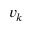Convert formula to latex. <formula><loc_0><loc_0><loc_500><loc_500>{ v } _ { k }</formula> 